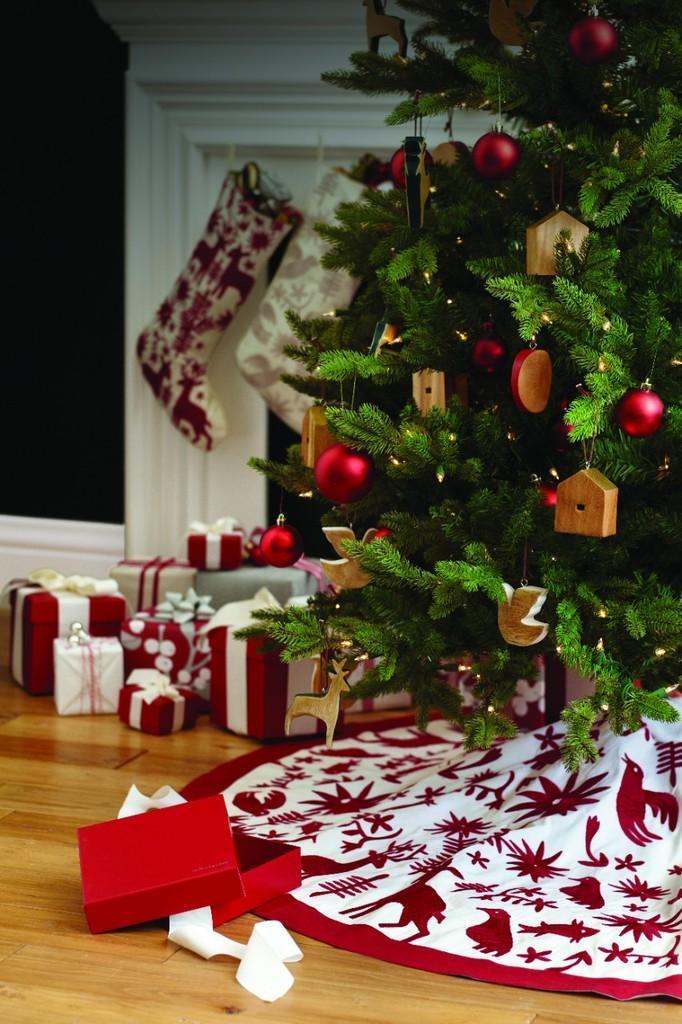Describe this image in one or two sentences. In this image in the middle, there are gifts, toys, Christmas tree, balls, decorations, cloth, tissues, shocks. At the bottom there is a floor. 